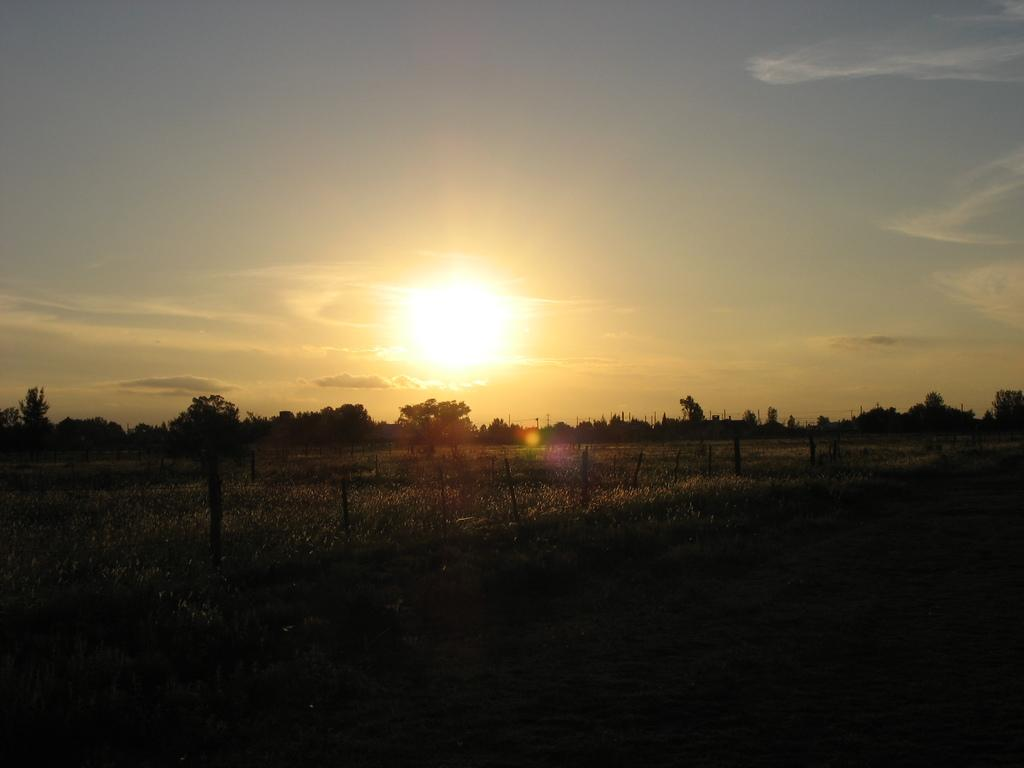What structures are present in the image? There are poles in the image. What type of vegetation can be seen in the image? There is grass and trees in the image. What is visible in the sky in the image? The sky is visible in the image, with clouds and the sun present. How many pizzas are being served at the event in the image? There is no event or pizzas present in the image; it features poles, grass, trees, and a sky with clouds and the sun. 